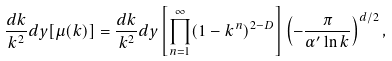Convert formula to latex. <formula><loc_0><loc_0><loc_500><loc_500>\frac { d k } { k ^ { 2 } } d y [ \mu ( k ) ] = \frac { d k } { k ^ { 2 } } d y \left [ \prod _ { n = 1 } ^ { \infty } ( 1 - k ^ { n } ) ^ { 2 - D } \right ] \left ( - \frac { \pi } { \alpha ^ { \prime } \ln k } \right ) ^ { d / 2 } ,</formula> 